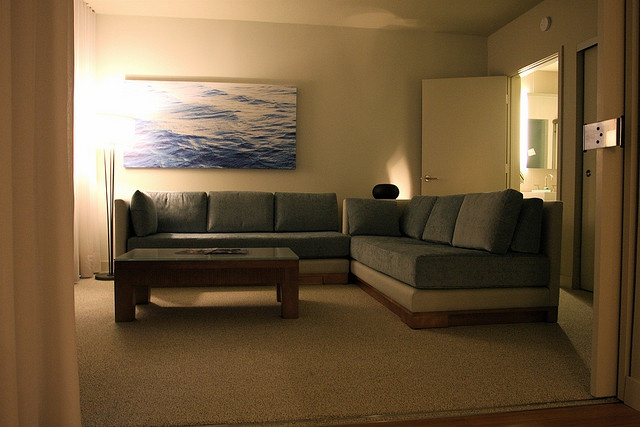Describe the objects in this image and their specific colors. I can see couch in maroon, black, and gray tones and sink in maroon, lightyellow, khaki, tan, and aquamarine tones in this image. 